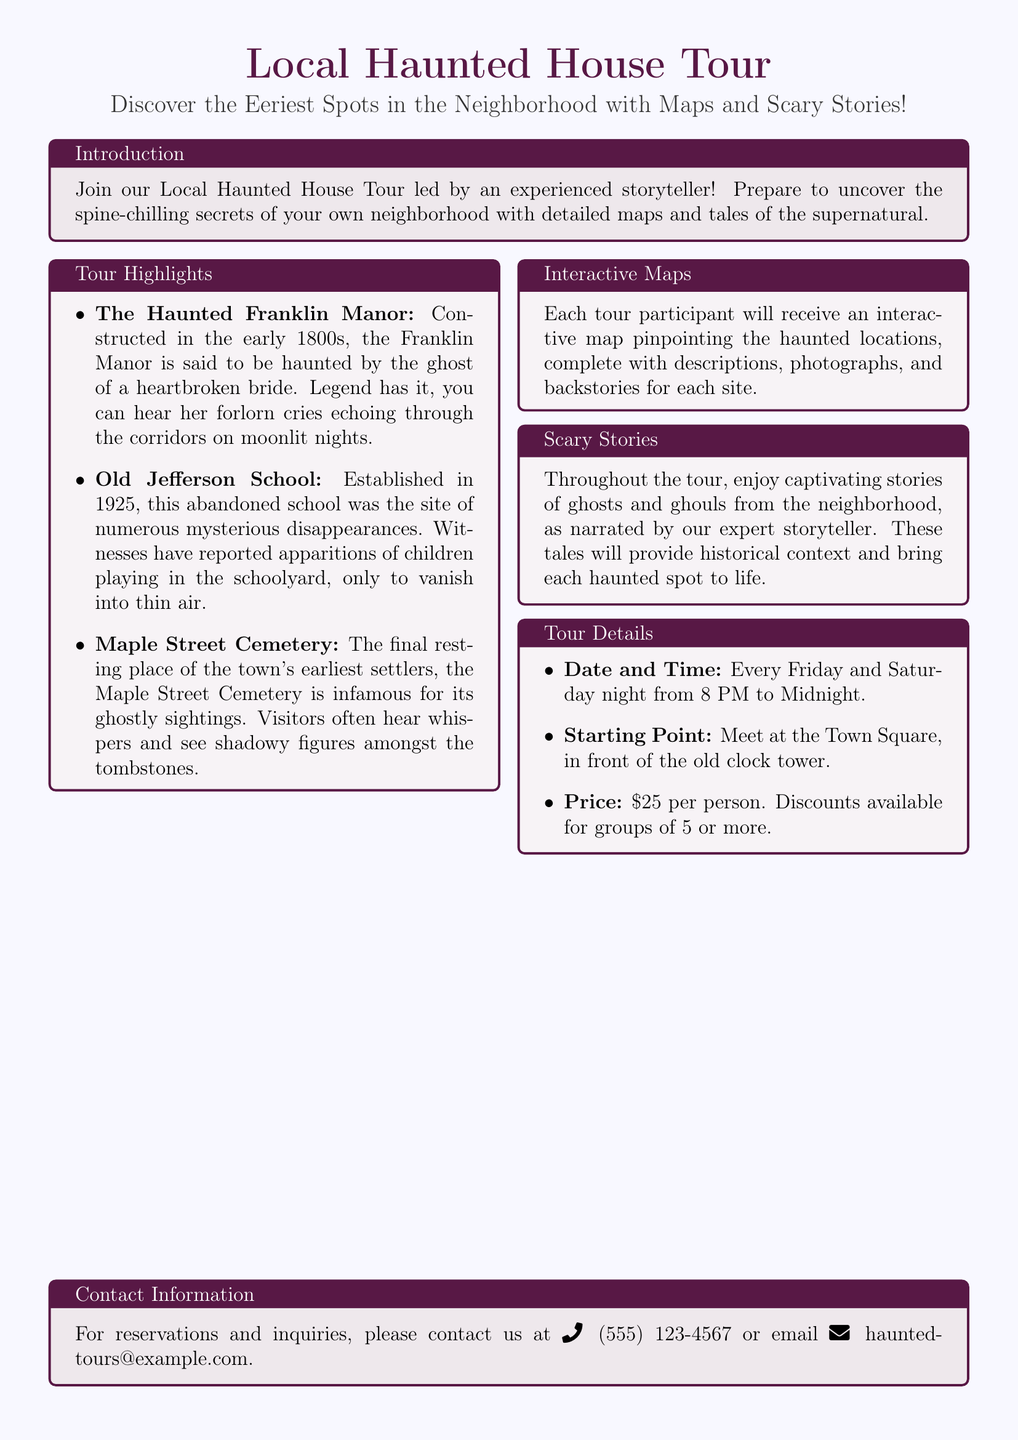What is the name of the haunted house featured on the tour? The document lists the Haunted Franklin Manor as one of the key attractions.
Answer: Haunted Franklin Manor What is the starting point for the tour? The document specifies that participants should meet at the Town Square in front of the old clock tower.
Answer: Town Square What days of the week does the tour take place? According to the document, the tours are held every Friday and Saturday night.
Answer: Friday and Saturday How much does the tour cost per person? The price for the tour per person, as stated in the document, is $25.
Answer: $25 What is included in the interactive maps provided? The document mentions that the maps include descriptions, photographs, and backstories for each site.
Answer: Descriptions, photographs, and backstories What type of stories will be narrated during the tour? The document indicates that captivating stories of ghosts and ghouls will be narrated.
Answer: Ghosts and ghouls How long does the tour last each night? The tour is scheduled from 8 PM to Midnight, meaning it lasts for four hours each night.
Answer: Four hours What is the contact phone number for the tour? The document provides the phone number as (555) 123-4567 for reservations and inquiries.
Answer: (555) 123-4567 